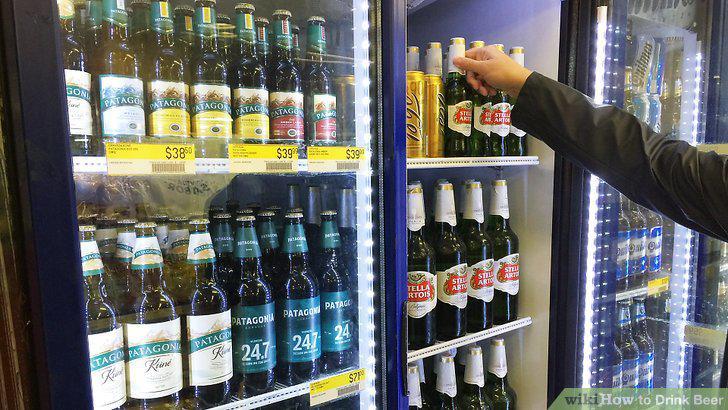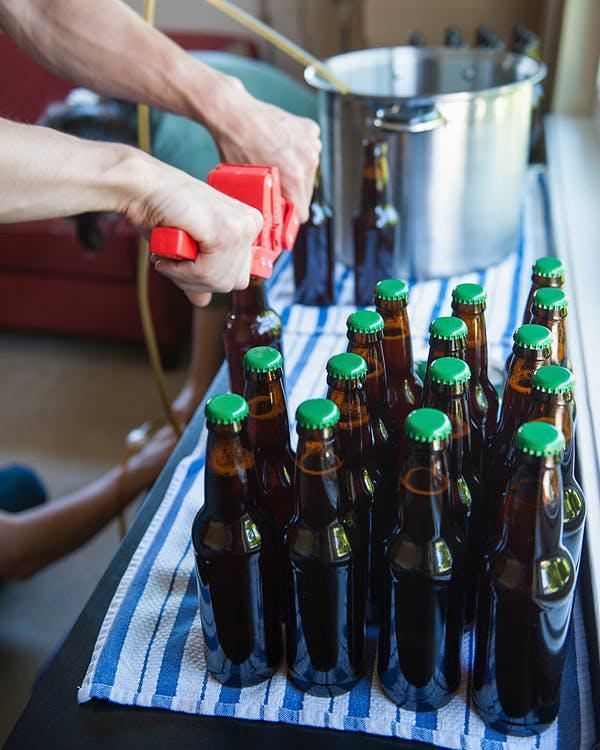The first image is the image on the left, the second image is the image on the right. Assess this claim about the two images: "In at least one image there are two people holding beer bottles.". Correct or not? Answer yes or no. No. The first image is the image on the left, the second image is the image on the right. For the images displayed, is the sentence "In the right image, one person is lifting a glass bottle to drink, with their head tilted back." factually correct? Answer yes or no. No. 